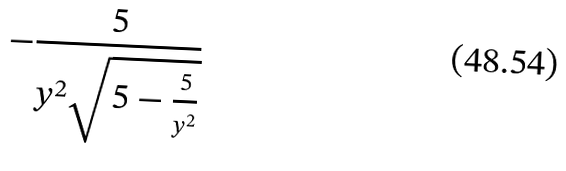Convert formula to latex. <formula><loc_0><loc_0><loc_500><loc_500>- \frac { 5 } { y ^ { 2 } \sqrt { 5 - \frac { 5 } { y ^ { 2 } } } }</formula> 